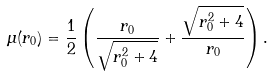Convert formula to latex. <formula><loc_0><loc_0><loc_500><loc_500>\mu ( r _ { 0 } ) = \frac { 1 } { 2 } \left ( \frac { r _ { 0 } } { \sqrt { r _ { 0 } ^ { 2 } + 4 } } + \frac { \sqrt { r _ { 0 } ^ { 2 } + 4 } } { r _ { 0 } } \right ) .</formula> 